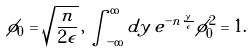Convert formula to latex. <formula><loc_0><loc_0><loc_500><loc_500>\phi _ { 0 } = \sqrt { \frac { n } { 2 \epsilon } } \, , \, \int _ { - \infty } ^ { \infty } d y \, e ^ { - n \frac { | y | } { \epsilon } } \phi _ { 0 } ^ { 2 } = 1 .</formula> 